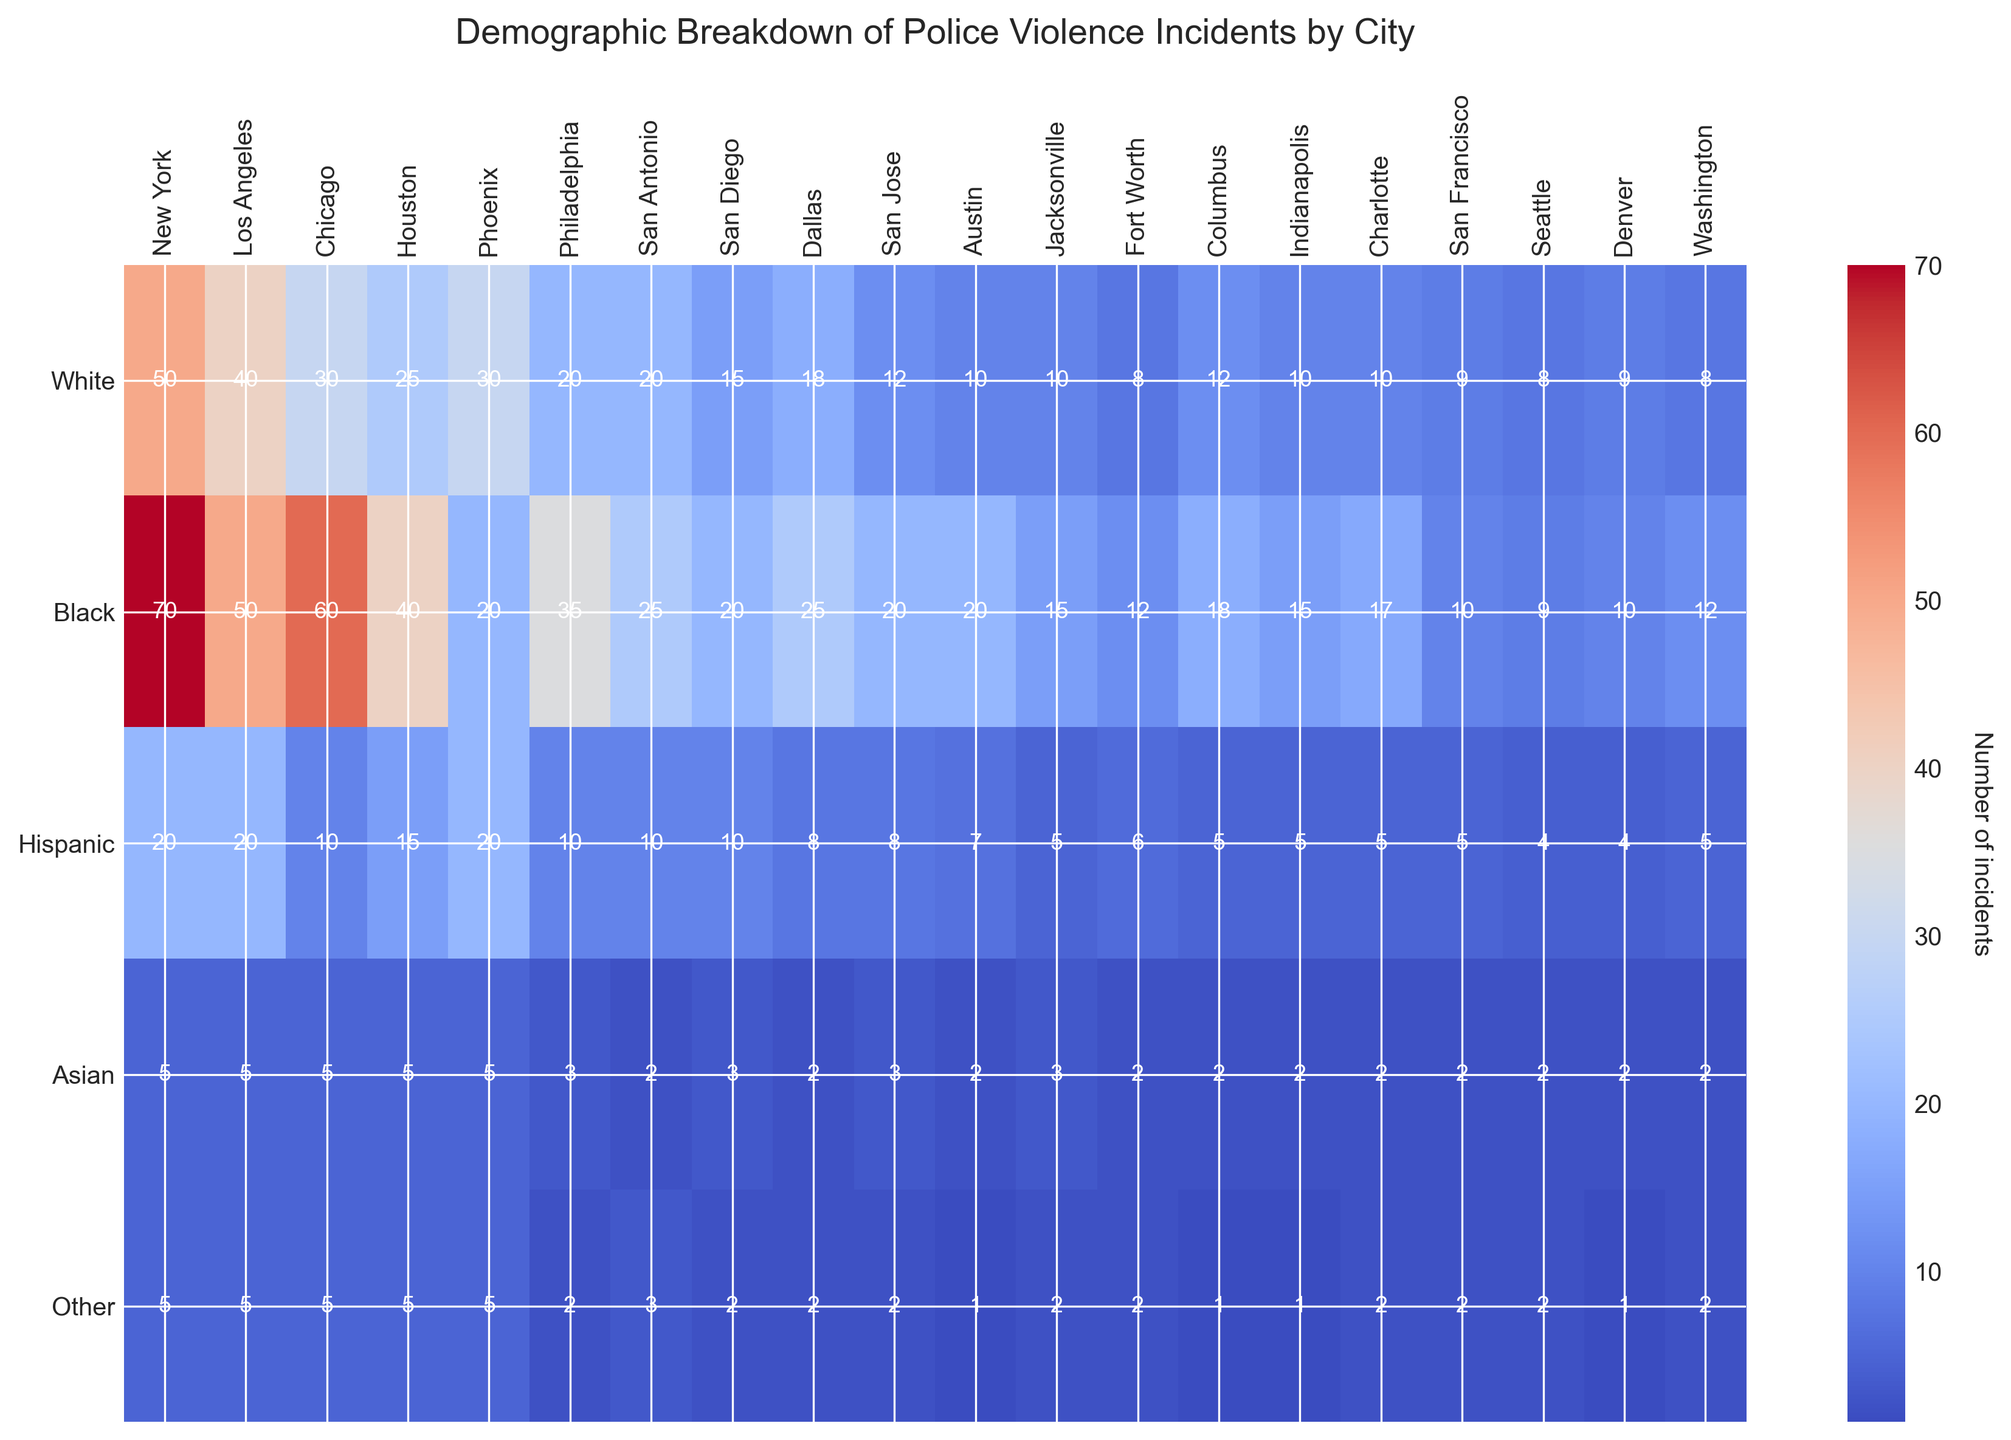Which city has the highest number of police violence incidents involving black victims? To determine this, look for the row labeled 'Black' and identify the city column with the highest number. In the row corresponding to 'Black', the highest value is 70, which is under 'New York'.
Answer: New York Which demographic group in Los Angeles experiences the most incidents of police violence? For Los Angeles, compare the numbers across all demographic groups in the respective column. In the Los Angeles column, 'Black' victims have the highest value at 50.
Answer: Black What is the total number of police violence incidents in San Antonio involving Hispanic and White victims? For San Antonio, sum the values in the 'Hispanic' and 'White' categories. The value for 'Hispanic' is 10 and for 'White' is 20, so the total is 10 + 20.
Answer: 30 How many more incidents involve black victims in Chicago compared to Hispanic victims in the same city? In Chicago, subtract the number of incidents involving 'Hispanic' victims (10) from those involving 'Black' victims (60). Thus, 60 - 10 = 50.
Answer: 50 Which city has the least number of incidents involving Asian victims? Look for the row labeled 'Asian' and identify the column with the lowest number. The lowest values are 2, shared by Columbus, Indianapolis, and Austin.
Answer: Columbus, Indianapolis, Austin What is the average number of incidents involving White victims across all cities? Sum all the values in the 'White' victims' row and divide by the total number of cities. The values are 50+40+30+25+30+20+20+15+18+12+10+10+8+12+10+9+8+9+8 = 344. There are 19 cities, so the average is 344/19.
Answer: 18.11 Which city shows the most balance in incident frequency among different demographic groups? Identify the city whose incident numbers across different demographics are closest to each other. Los Angeles has balanced numbers among all groups: 40 (White), 50 (Black), 20 (Hispanic), 5 (Asian), and 5 (Other).
Answer: Los Angeles Which city has a significantly higher number of incidents for one demographic compared to others? Identify the city with one significantly higher value in comparison to others in its column. New York has 70 incidents for Black victims, significantly higher than for other demographics in that city.
Answer: New York How does the number of incidents involving other victims in Seattle compare to those in Phoenix? Compare the values under the 'Other' category for Seattle and Phoenix. Seattle has 2 incidents, and Phoenix has 5; thus, Phoenix has more incidents.
Answer: Phoenix What is the combined total of incidents involving Hispanic victims in Philadelphia and Austin? Sum the values listed under 'Hispanic' for Philadelphia (10) and Austin (7). The total is 10 + 7.
Answer: 17 